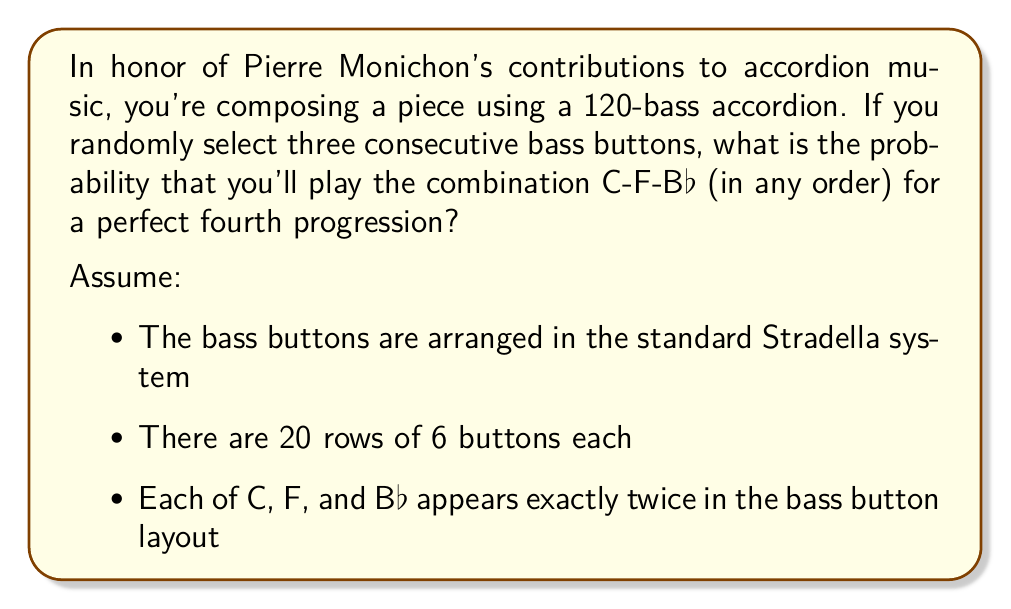Solve this math problem. To solve this problem, we need to consider the following steps:

1) First, let's calculate the total number of ways to select three consecutive bass buttons:
   - There are 20 rows with 6 buttons each, so 120 buttons total
   - We can start our selection from any of the first 118 buttons (as we need 3 consecutive)
   - Total number of ways = 118

2) Now, let's consider the favorable outcomes:
   - We need C, F, and Bb in any order
   - These can appear as: C-F-Bb, C-Bb-F, F-C-Bb, F-Bb-C, Bb-C-F, or Bb-F-C
   - Each of C, F, and Bb appears twice in the layout

3) To have a favorable outcome, we need these buttons to be adjacent. In the Stradella system, perfect fourths are typically adjacent vertically. So, we're looking for vertical arrangements of these notes.

4) Given the standard layout, there are typically 2 places where these notes would be adjacent vertically:
   - One column might have C-F-Bb
   - Another column might have F-Bb-C

5) For each of these 2 locations, we have 3 ways to select our 3 consecutive buttons (top 3, middle 3, or bottom 3).

6) Therefore, the total number of favorable outcomes is:
   2 locations × 3 ways each = 6

7) The probability is then:

   $$P(\text{C-F-Bb combination}) = \frac{\text{Favorable outcomes}}{\text{Total outcomes}} = \frac{6}{118} = \frac{3}{59}$$
Answer: $\frac{3}{59}$ or approximately 0.0508 or 5.08% 